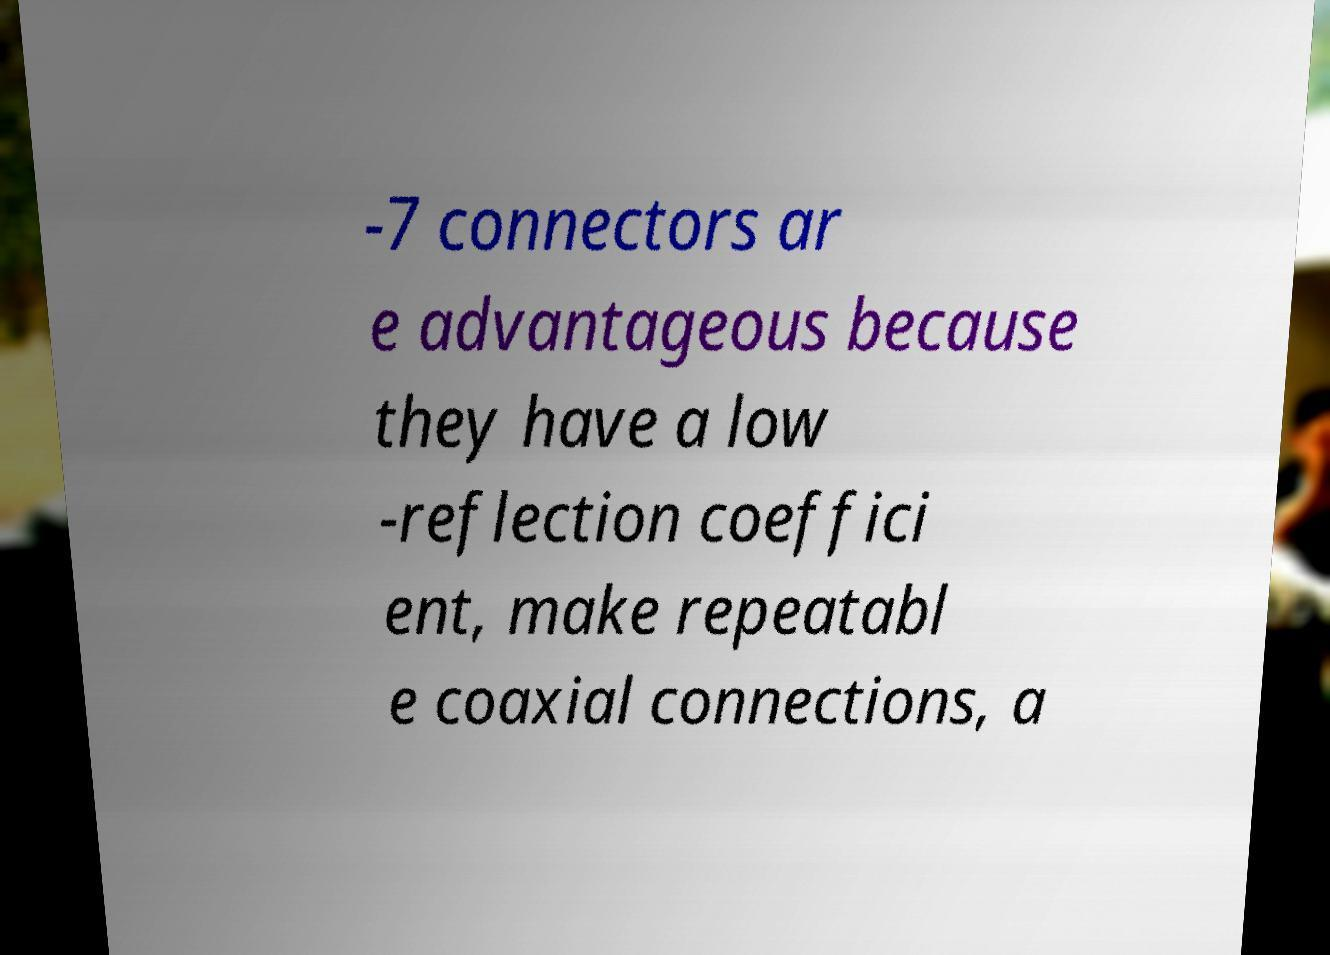Can you accurately transcribe the text from the provided image for me? -7 connectors ar e advantageous because they have a low -reflection coeffici ent, make repeatabl e coaxial connections, a 